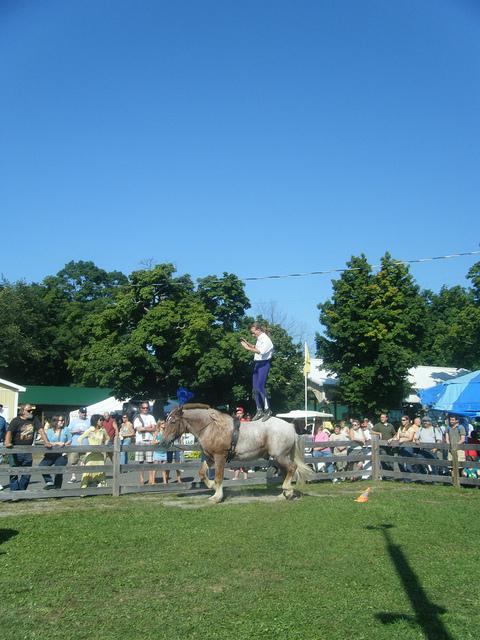How many horses?
Answer briefly. 1. What animal is in the competition?
Give a very brief answer. Horse. What are the spectators watching?
Give a very brief answer. Horse tricks. Is the horse running?
Be succinct. No. How many horses are eating grass?
Quick response, please. 0. What are the wooden posts for?
Quick response, please. Fencing. Is this a pretty landscape?
Keep it brief. Yes. How many people are wearing sunglasses?
Be succinct. 0. Do you require a strong breeze for this activity?
Write a very short answer. No. Is this a circus?
Give a very brief answer. No. What color horse is closer to the camera?
Be succinct. Tan. Is the man performing an act?
Answer briefly. Yes. 